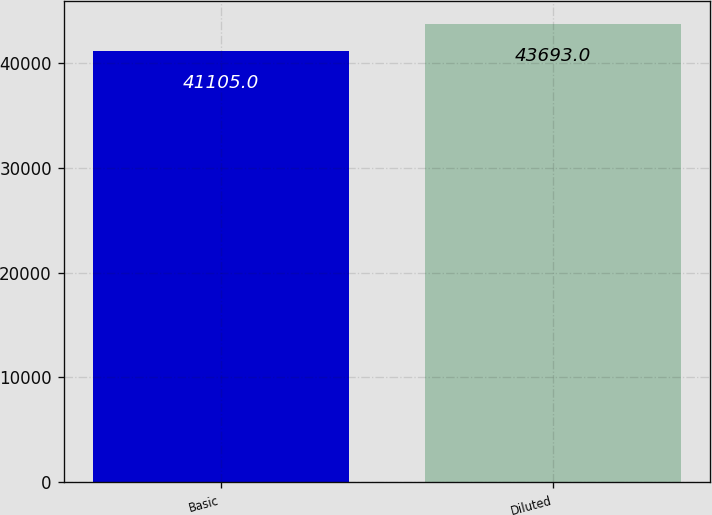<chart> <loc_0><loc_0><loc_500><loc_500><bar_chart><fcel>Basic<fcel>Diluted<nl><fcel>41105<fcel>43693<nl></chart> 